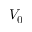Convert formula to latex. <formula><loc_0><loc_0><loc_500><loc_500>V _ { 0 }</formula> 